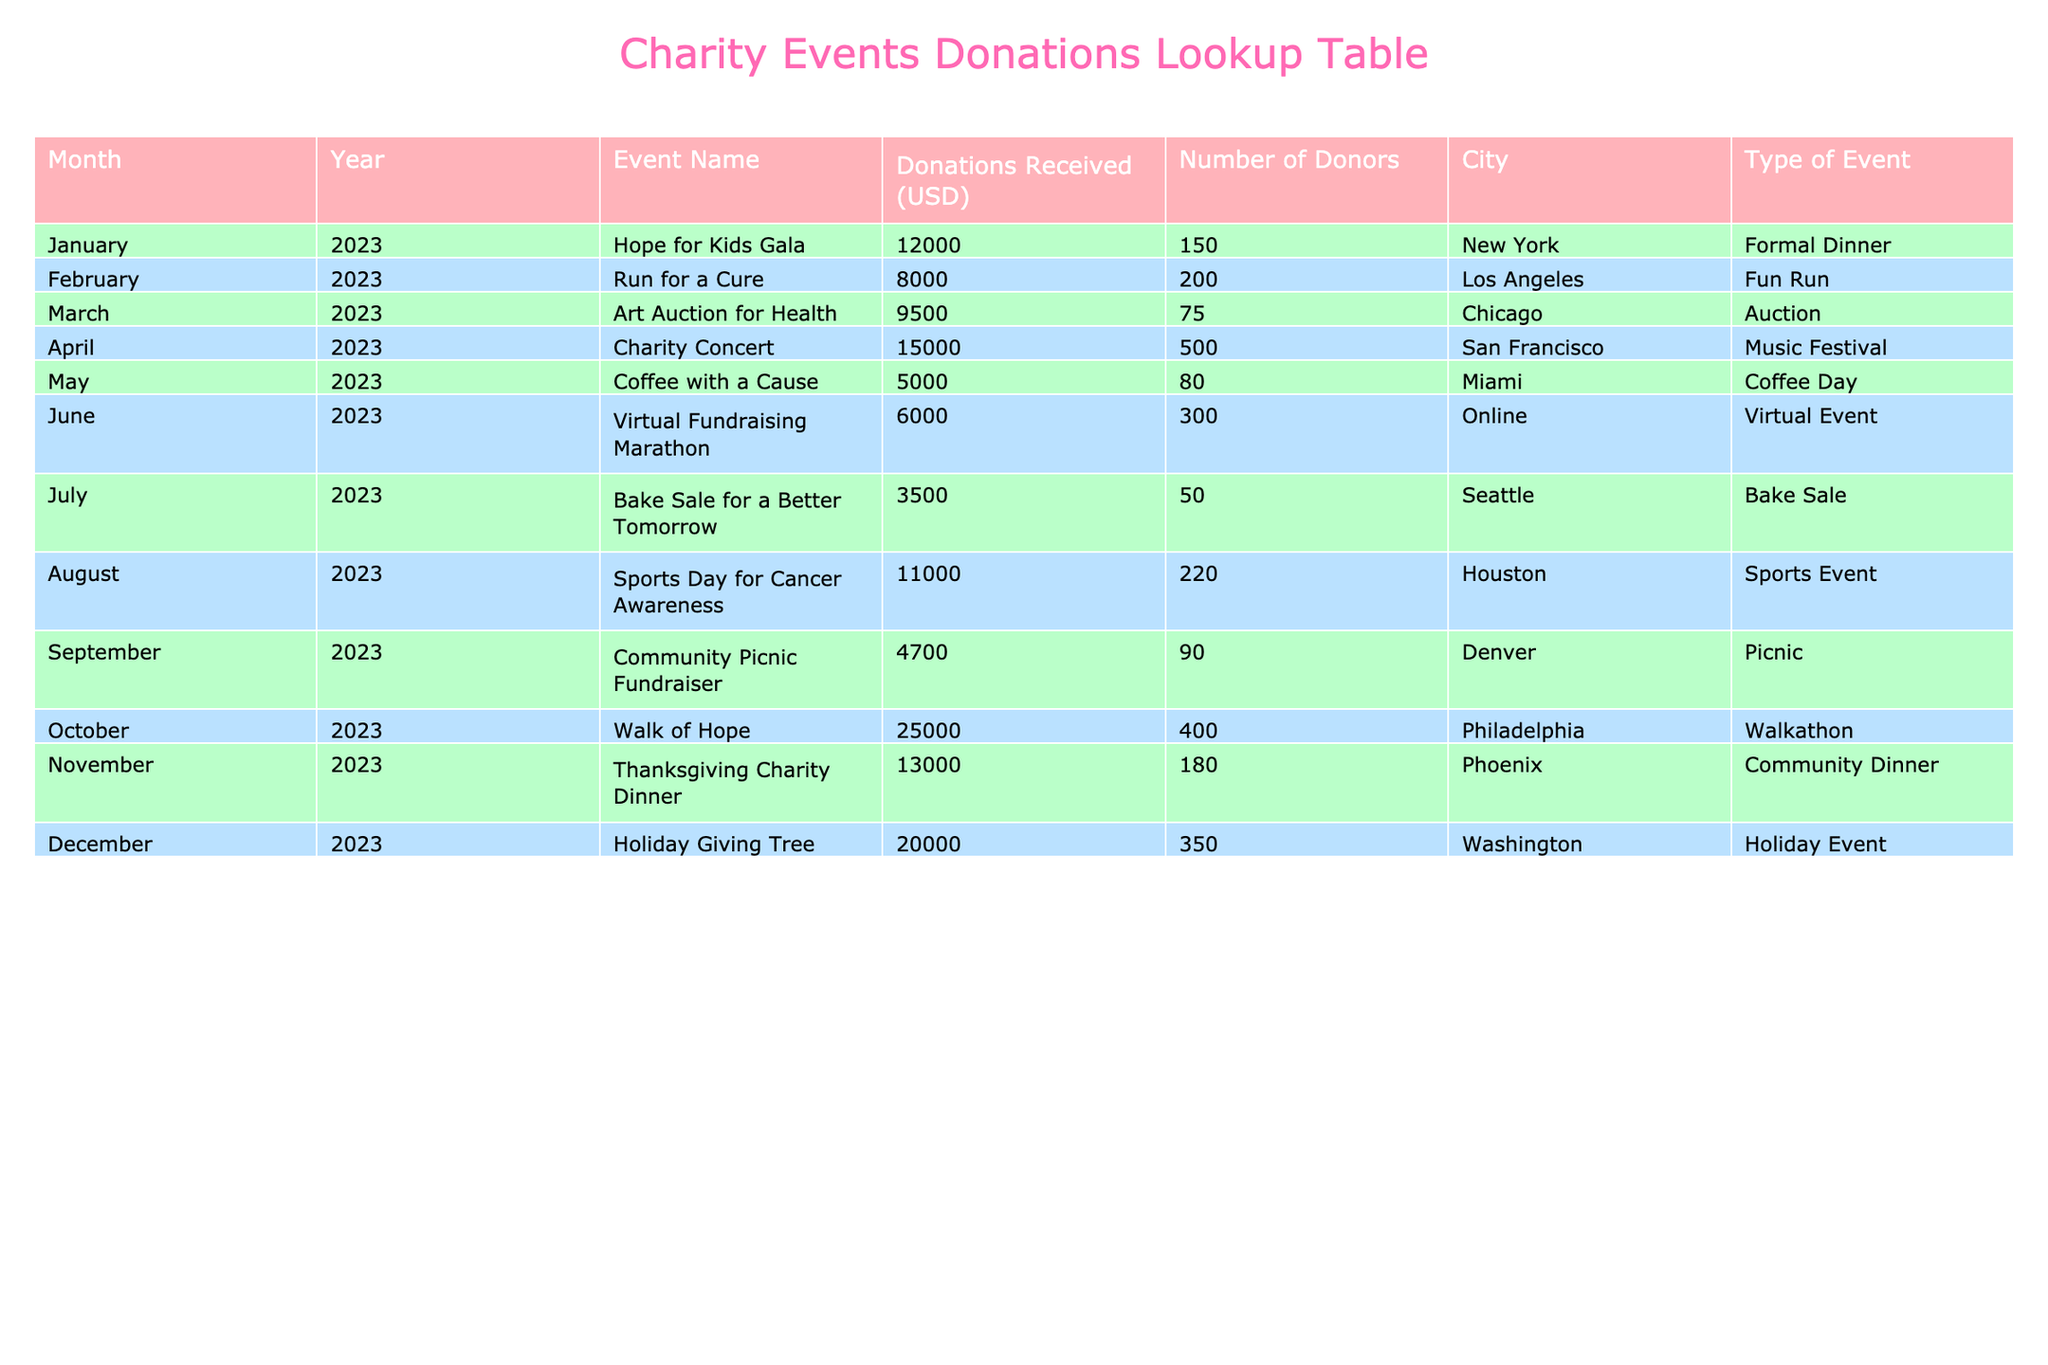What was the total amount of donations received in January 2023? The table shows that in January 2023, the event "Hope for Kids Gala" received 12,000 USD in donations.
Answer: 12,000 USD How many donors contributed to the "Walk of Hope" event? According to the table, the "Walk of Hope" event in October 2023 had 400 donors.
Answer: 400 Which event had the highest donations received, and what was the amount? The table indicates that "Walk of Hope" in October 2023 received the most donations, amounting to 25,000 USD.
Answer: Walk of Hope, 25,000 USD What is the average donation amount for events that took place in April and December 2023? In April 2023, "Charity Concert" received 15,000 USD and in December 2023, "Holiday Giving Tree" received 20,000 USD. The average is (15,000 + 20,000) / 2 = 17,500 USD.
Answer: 17,500 USD Did the "Bake Sale for a Better Tomorrow" event receive more or less than 5,000 USD? The table states that "Bake Sale for a Better Tomorrow" in July 2023 received 3,500 USD, which is less than 5,000 USD.
Answer: Less What was the total number of donors for all events held in 2023? To find the total, sum the number of donors from all events: 150 + 200 + 75 + 500 + 80 + 300 + 50 + 220 + 90 + 400 + 180 + 350 = 2,145.
Answer: 2,145 How much more did the "Charity Concert" earn compared to the "Community Picnic Fundraiser"? The "Charity Concert" received 15,000 USD and the "Community Picnic Fundraiser" received 4,700 USD. The difference is 15,000 - 4,700 = 10,300 USD.
Answer: 10,300 USD Was the average donation amount across all events greater than 10,000 USD? The total donations from the 12 events is (12,000 + 8,000 + 9,500 + 15,000 + 5,000 + 6,000 + 3,500 + 11,000 + 4,700 + 25,000 + 13,000 + 20,000) =  3,51800 USD and the average is 3,51800 / 12 = 5,598.33 USD, which is less than 10,000 USD.
Answer: No Which city had the event with the least amount of donations, and what was the event name? Referring to the table, the least donations were from the "Bake Sale for a Better Tomorrow" event in Seattle, which received 3,500 USD.
Answer: Seattle, Bake Sale for a Better Tomorrow 